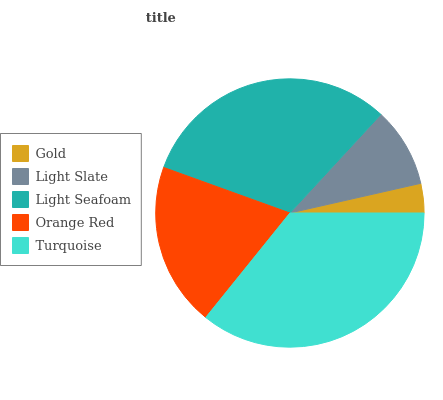Is Gold the minimum?
Answer yes or no. Yes. Is Turquoise the maximum?
Answer yes or no. Yes. Is Light Slate the minimum?
Answer yes or no. No. Is Light Slate the maximum?
Answer yes or no. No. Is Light Slate greater than Gold?
Answer yes or no. Yes. Is Gold less than Light Slate?
Answer yes or no. Yes. Is Gold greater than Light Slate?
Answer yes or no. No. Is Light Slate less than Gold?
Answer yes or no. No. Is Orange Red the high median?
Answer yes or no. Yes. Is Orange Red the low median?
Answer yes or no. Yes. Is Light Seafoam the high median?
Answer yes or no. No. Is Turquoise the low median?
Answer yes or no. No. 